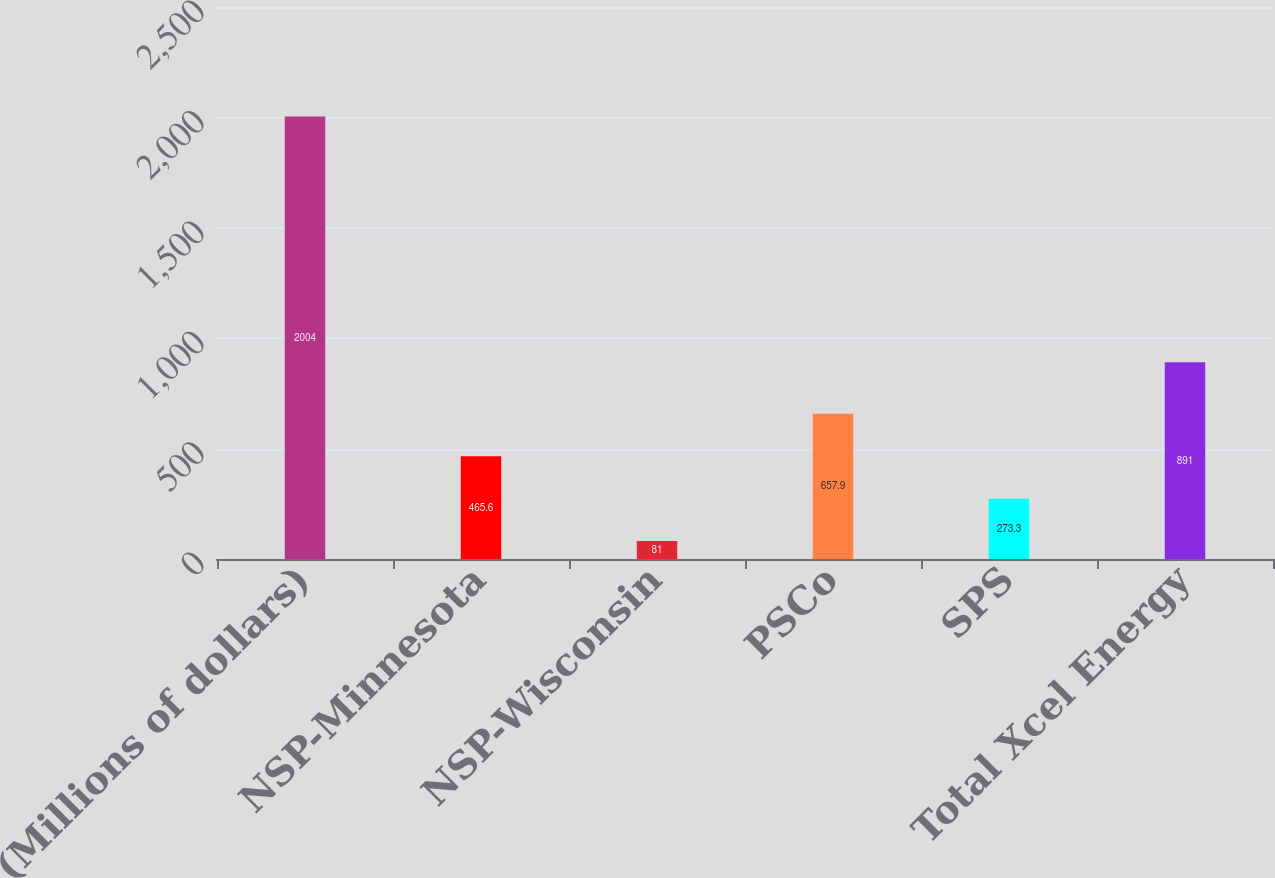Convert chart. <chart><loc_0><loc_0><loc_500><loc_500><bar_chart><fcel>(Millions of dollars)<fcel>NSP-Minnesota<fcel>NSP-Wisconsin<fcel>PSCo<fcel>SPS<fcel>Total Xcel Energy<nl><fcel>2004<fcel>465.6<fcel>81<fcel>657.9<fcel>273.3<fcel>891<nl></chart> 